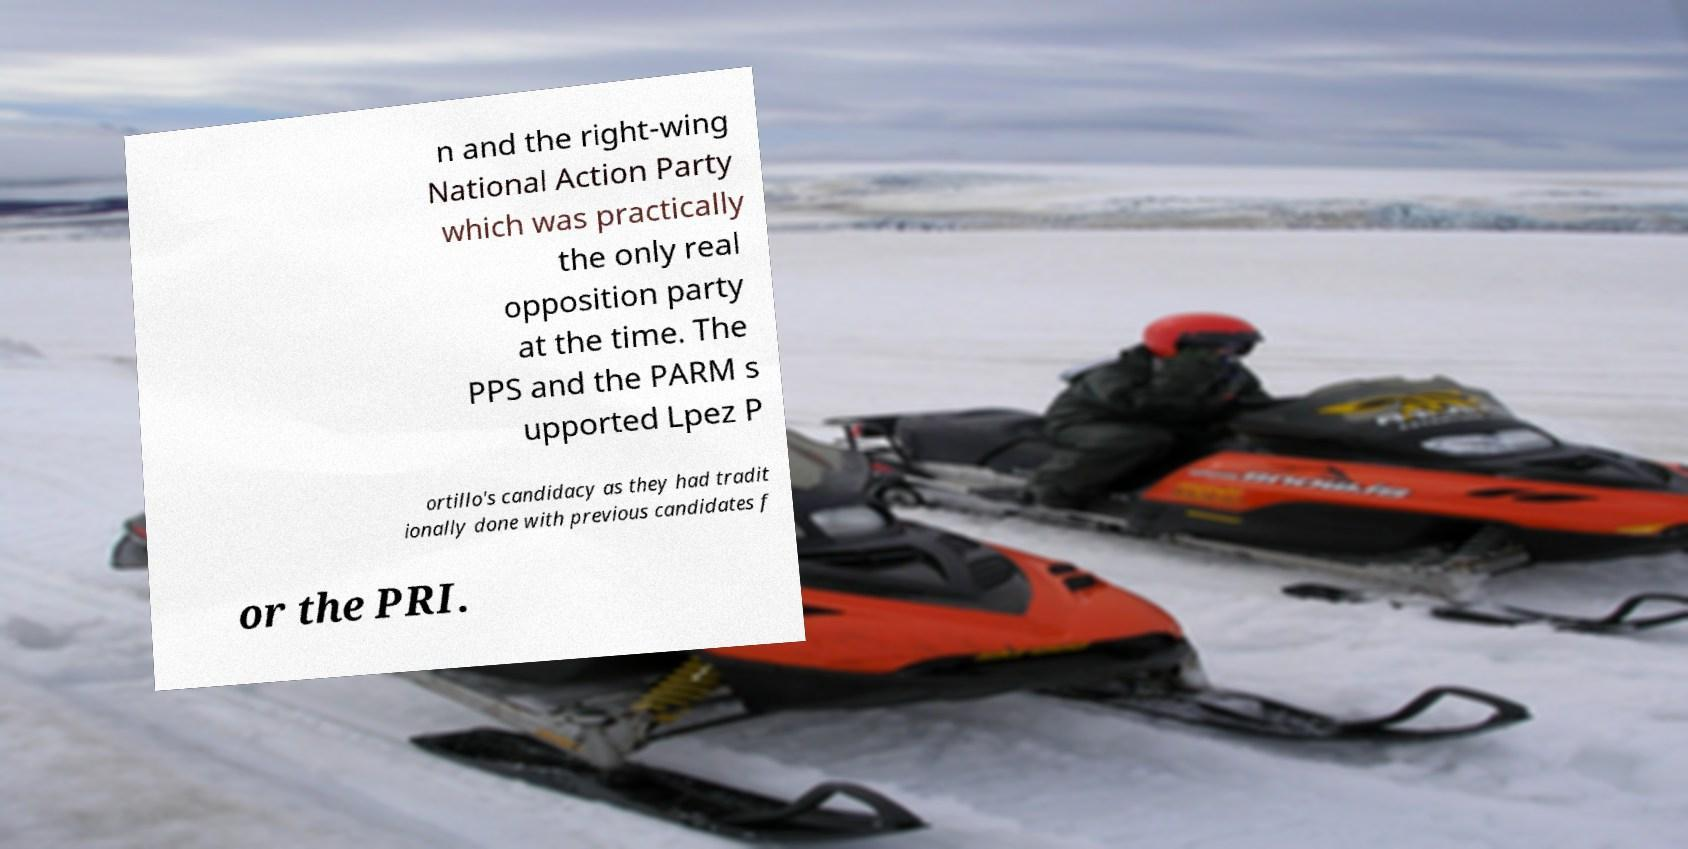For documentation purposes, I need the text within this image transcribed. Could you provide that? n and the right-wing National Action Party which was practically the only real opposition party at the time. The PPS and the PARM s upported Lpez P ortillo's candidacy as they had tradit ionally done with previous candidates f or the PRI. 